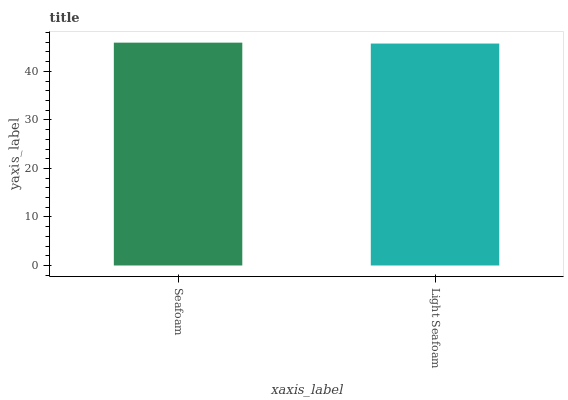Is Light Seafoam the minimum?
Answer yes or no. Yes. Is Seafoam the maximum?
Answer yes or no. Yes. Is Light Seafoam the maximum?
Answer yes or no. No. Is Seafoam greater than Light Seafoam?
Answer yes or no. Yes. Is Light Seafoam less than Seafoam?
Answer yes or no. Yes. Is Light Seafoam greater than Seafoam?
Answer yes or no. No. Is Seafoam less than Light Seafoam?
Answer yes or no. No. Is Seafoam the high median?
Answer yes or no. Yes. Is Light Seafoam the low median?
Answer yes or no. Yes. Is Light Seafoam the high median?
Answer yes or no. No. Is Seafoam the low median?
Answer yes or no. No. 